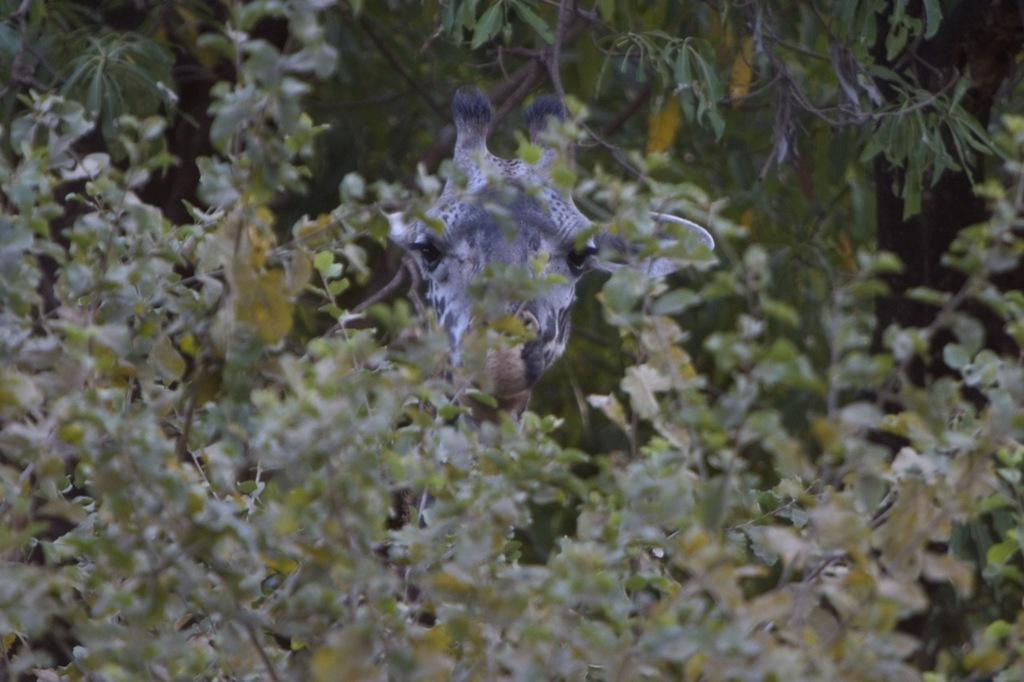How would you summarize this image in a sentence or two? This image is taken outdoors. In the background there are a few trees and there is a giraffe. In the middle of the image there are many plants with leaves and stems. Those leaves are green in color. 